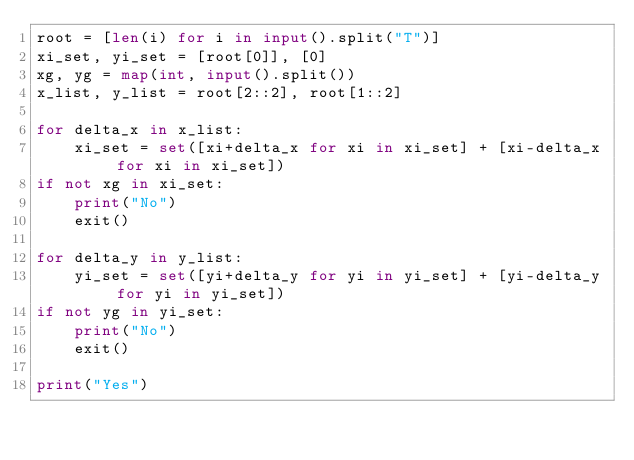Convert code to text. <code><loc_0><loc_0><loc_500><loc_500><_Python_>root = [len(i) for i in input().split("T")]
xi_set, yi_set = [root[0]], [0]
xg, yg = map(int, input().split())
x_list, y_list = root[2::2], root[1::2]

for delta_x in x_list:
    xi_set = set([xi+delta_x for xi in xi_set] + [xi-delta_x for xi in xi_set])
if not xg in xi_set:
    print("No")
    exit()
    
for delta_y in y_list:
    yi_set = set([yi+delta_y for yi in yi_set] + [yi-delta_y for yi in yi_set])
if not yg in yi_set:
    print("No")
    exit()

print("Yes")</code> 